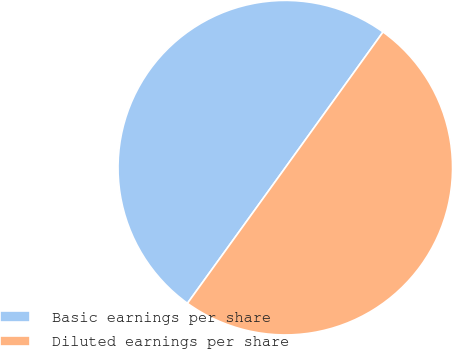<chart> <loc_0><loc_0><loc_500><loc_500><pie_chart><fcel>Basic earnings per share<fcel>Diluted earnings per share<nl><fcel>49.99%<fcel>50.01%<nl></chart> 